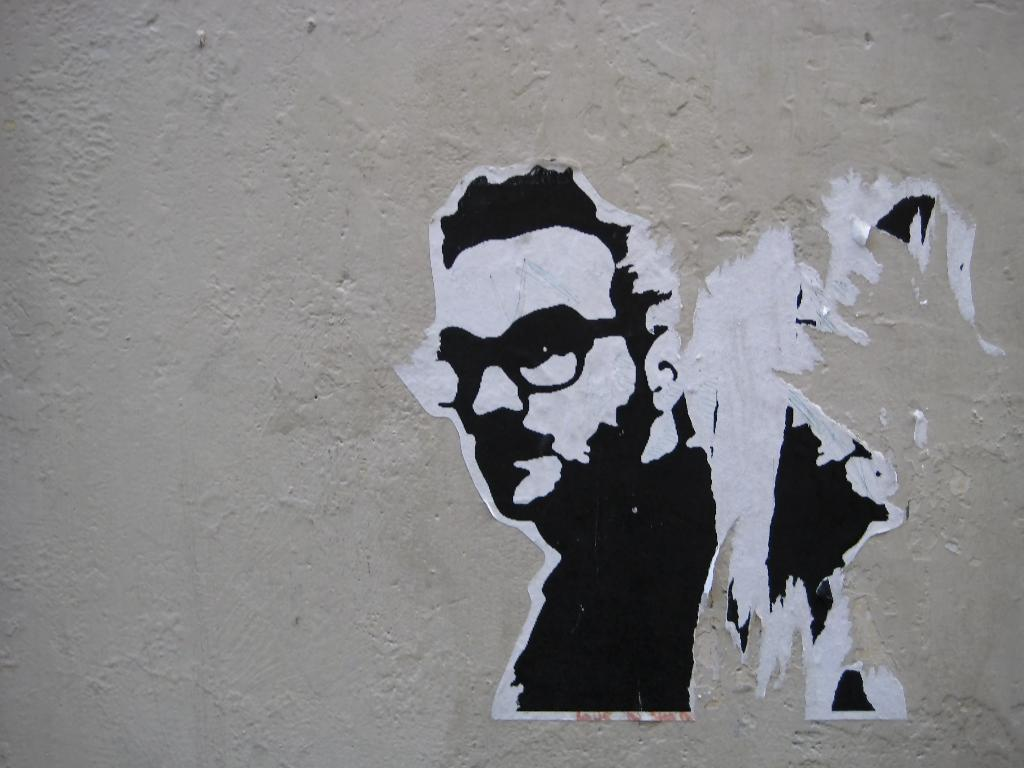What is depicted on the poster in the image? The poster is of a person. Where is the poster located in the image? The poster is on a wall. What type of cloth is used to make the whistle in the image? There is no whistle present in the image, so it is not possible to determine what type of cloth might be used to make it. 